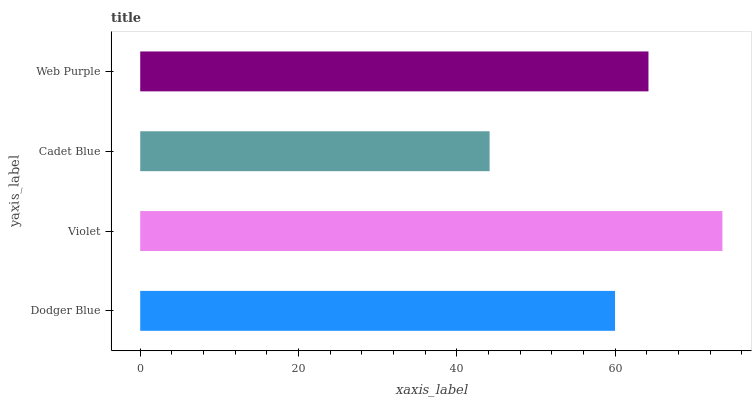Is Cadet Blue the minimum?
Answer yes or no. Yes. Is Violet the maximum?
Answer yes or no. Yes. Is Violet the minimum?
Answer yes or no. No. Is Cadet Blue the maximum?
Answer yes or no. No. Is Violet greater than Cadet Blue?
Answer yes or no. Yes. Is Cadet Blue less than Violet?
Answer yes or no. Yes. Is Cadet Blue greater than Violet?
Answer yes or no. No. Is Violet less than Cadet Blue?
Answer yes or no. No. Is Web Purple the high median?
Answer yes or no. Yes. Is Dodger Blue the low median?
Answer yes or no. Yes. Is Cadet Blue the high median?
Answer yes or no. No. Is Violet the low median?
Answer yes or no. No. 